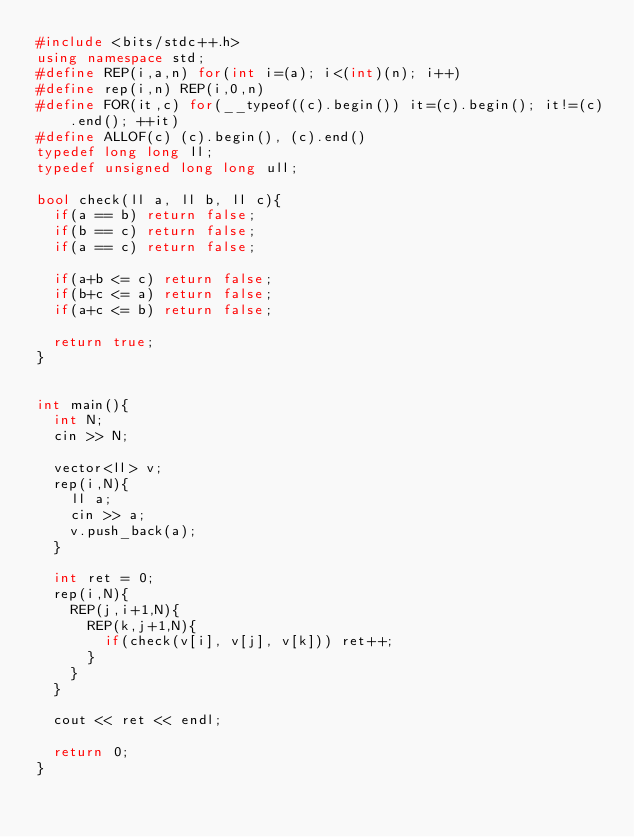Convert code to text. <code><loc_0><loc_0><loc_500><loc_500><_C++_>#include <bits/stdc++.h>
using namespace std;
#define REP(i,a,n) for(int i=(a); i<(int)(n); i++)
#define rep(i,n) REP(i,0,n)
#define FOR(it,c) for(__typeof((c).begin()) it=(c).begin(); it!=(c).end(); ++it)
#define ALLOF(c) (c).begin(), (c).end()
typedef long long ll;
typedef unsigned long long ull;

bool check(ll a, ll b, ll c){
  if(a == b) return false;
  if(b == c) return false;
  if(a == c) return false;

  if(a+b <= c) return false;
  if(b+c <= a) return false;
  if(a+c <= b) return false;

  return true;
}


int main(){
  int N;
  cin >> N;

  vector<ll> v;
  rep(i,N){
    ll a;
    cin >> a;
    v.push_back(a);
  }

  int ret = 0;
  rep(i,N){
    REP(j,i+1,N){
      REP(k,j+1,N){
        if(check(v[i], v[j], v[k])) ret++;
      }
    }
  }
  
  cout << ret << endl;
  
  return 0;
}
</code> 